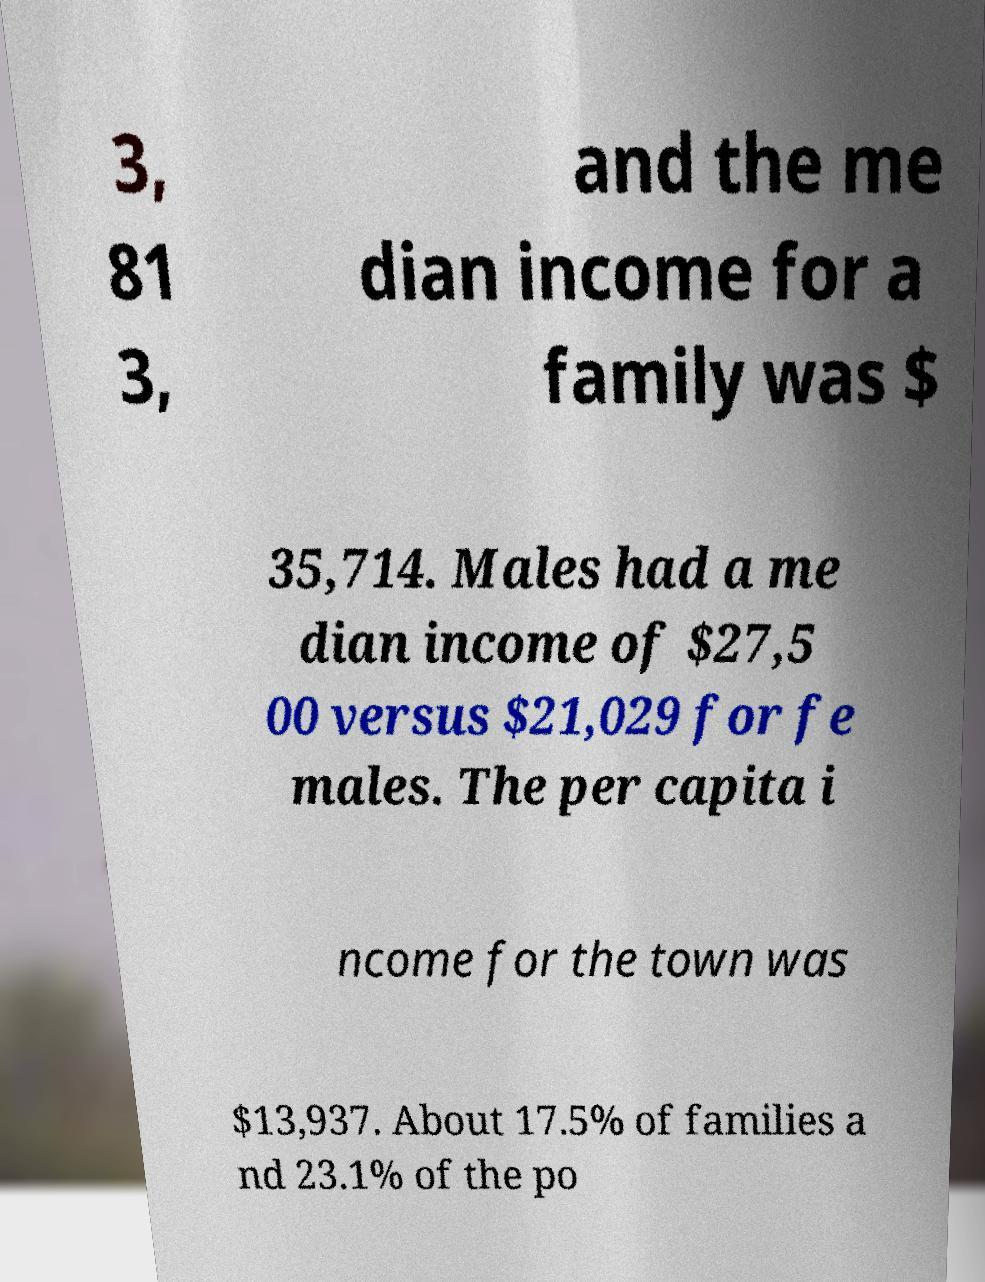What messages or text are displayed in this image? I need them in a readable, typed format. 3, 81 3, and the me dian income for a family was $ 35,714. Males had a me dian income of $27,5 00 versus $21,029 for fe males. The per capita i ncome for the town was $13,937. About 17.5% of families a nd 23.1% of the po 